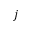Convert formula to latex. <formula><loc_0><loc_0><loc_500><loc_500>j</formula> 